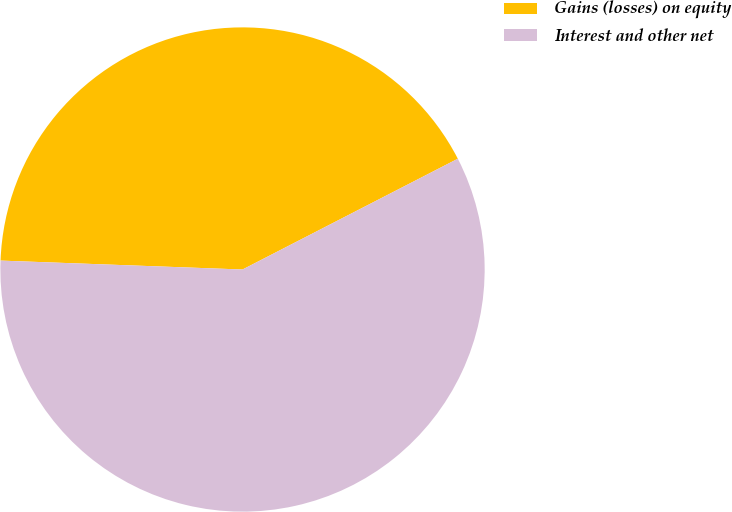<chart> <loc_0><loc_0><loc_500><loc_500><pie_chart><fcel>Gains (losses) on equity<fcel>Interest and other net<nl><fcel>41.85%<fcel>58.15%<nl></chart> 